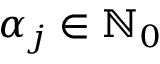Convert formula to latex. <formula><loc_0><loc_0><loc_500><loc_500>\alpha _ { j } \in { \mathbb { N } } _ { 0 }</formula> 